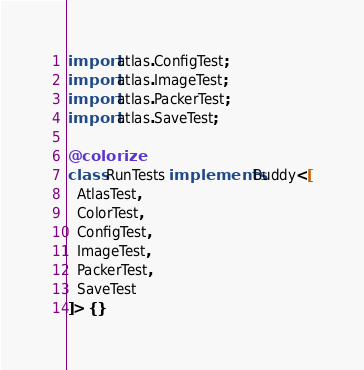<code> <loc_0><loc_0><loc_500><loc_500><_Haxe_>import atlas.ConfigTest;
import atlas.ImageTest;
import atlas.PackerTest;
import atlas.SaveTest;

@colorize
class RunTests implements Buddy<[
  AtlasTest,
  ColorTest,
  ConfigTest,
  ImageTest,
  PackerTest,
  SaveTest
]> {}</code> 